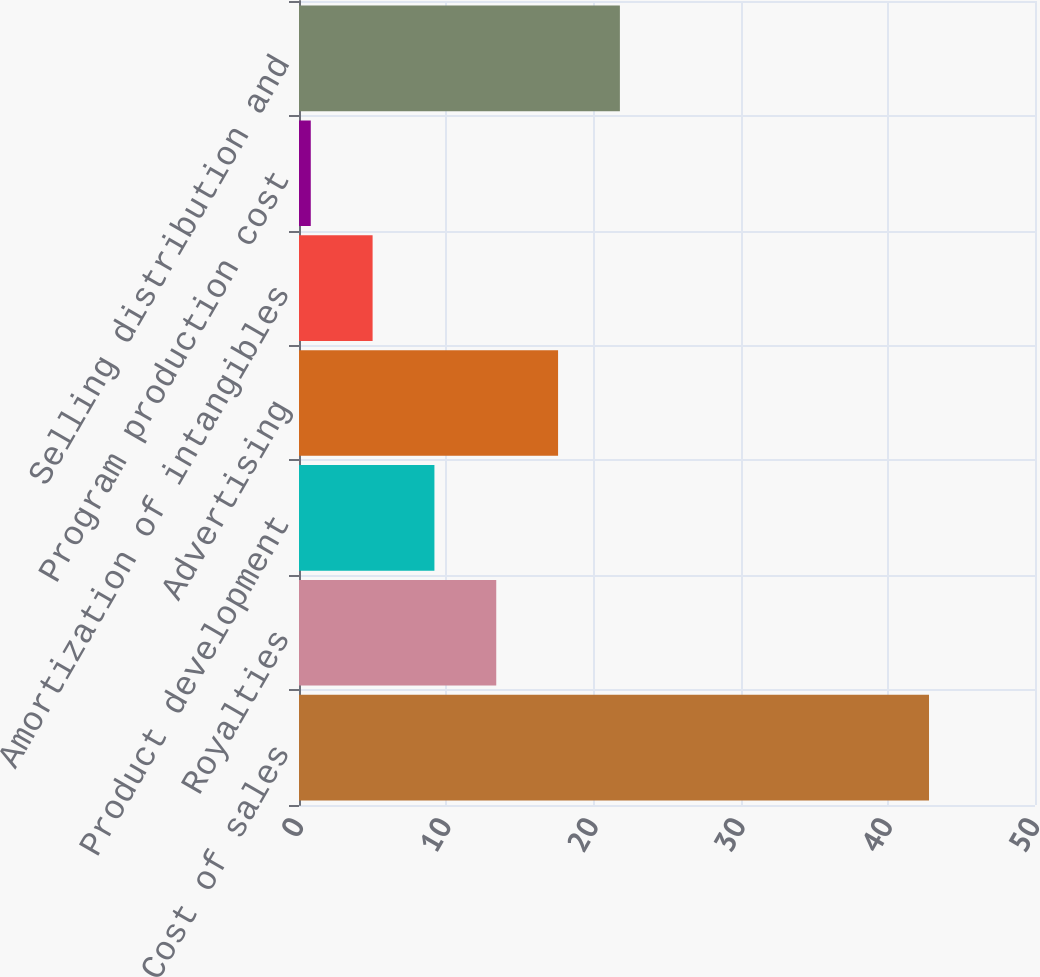Convert chart. <chart><loc_0><loc_0><loc_500><loc_500><bar_chart><fcel>Cost of sales<fcel>Royalties<fcel>Product development<fcel>Advertising<fcel>Amortization of intangibles<fcel>Program production cost<fcel>Selling distribution and<nl><fcel>42.8<fcel>13.4<fcel>9.2<fcel>17.6<fcel>5<fcel>0.8<fcel>21.8<nl></chart> 